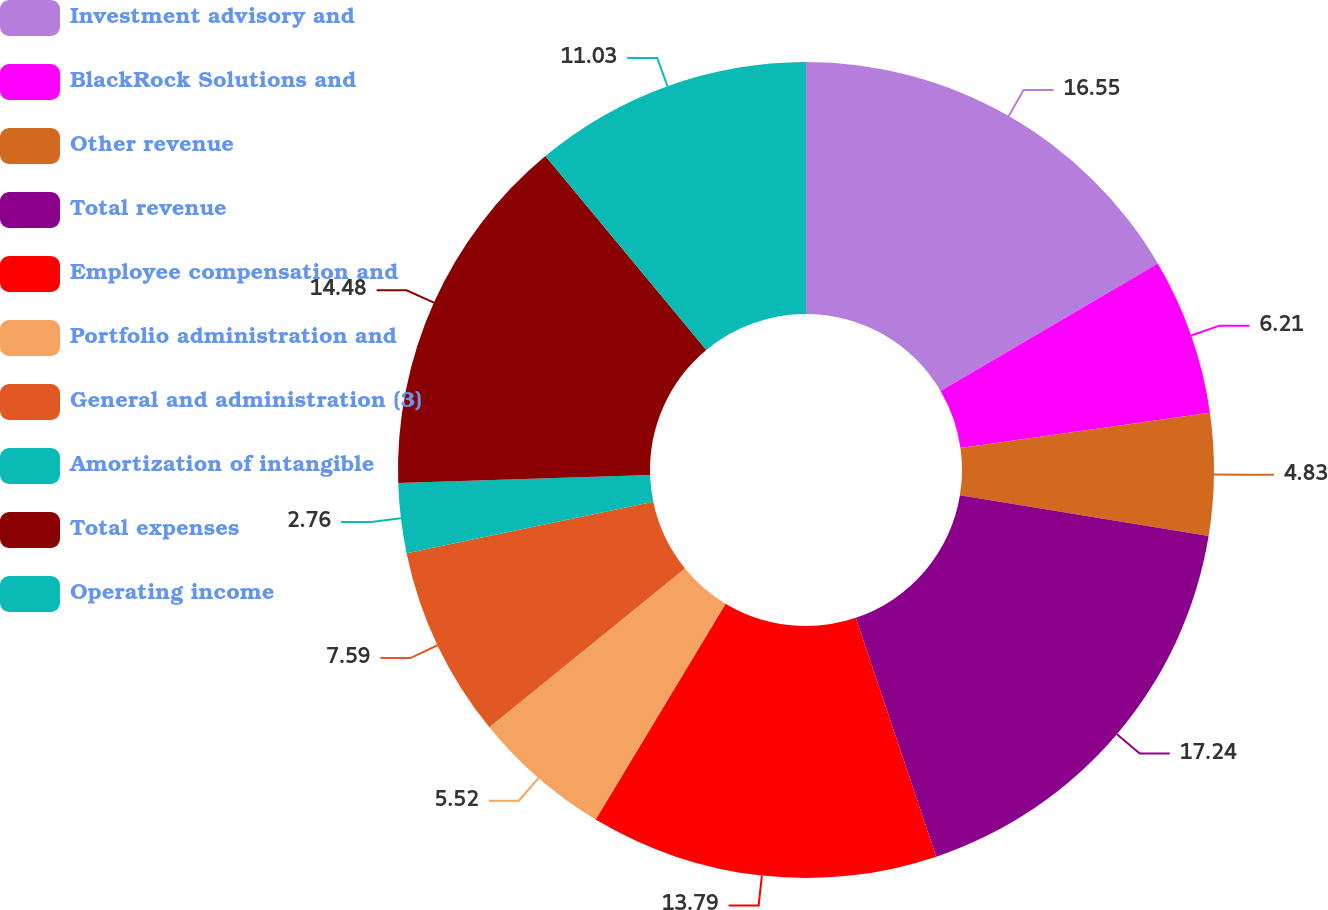<chart> <loc_0><loc_0><loc_500><loc_500><pie_chart><fcel>Investment advisory and<fcel>BlackRock Solutions and<fcel>Other revenue<fcel>Total revenue<fcel>Employee compensation and<fcel>Portfolio administration and<fcel>General and administration (3)<fcel>Amortization of intangible<fcel>Total expenses<fcel>Operating income<nl><fcel>16.55%<fcel>6.21%<fcel>4.83%<fcel>17.24%<fcel>13.79%<fcel>5.52%<fcel>7.59%<fcel>2.76%<fcel>14.48%<fcel>11.03%<nl></chart> 